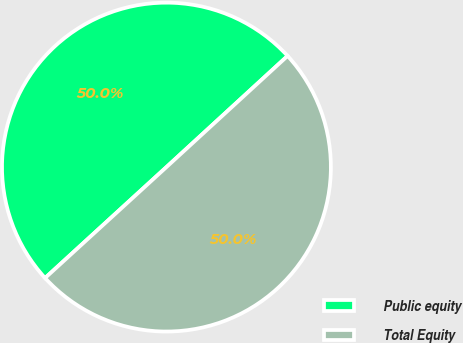Convert chart. <chart><loc_0><loc_0><loc_500><loc_500><pie_chart><fcel>Public equity<fcel>Total Equity<nl><fcel>49.97%<fcel>50.03%<nl></chart> 